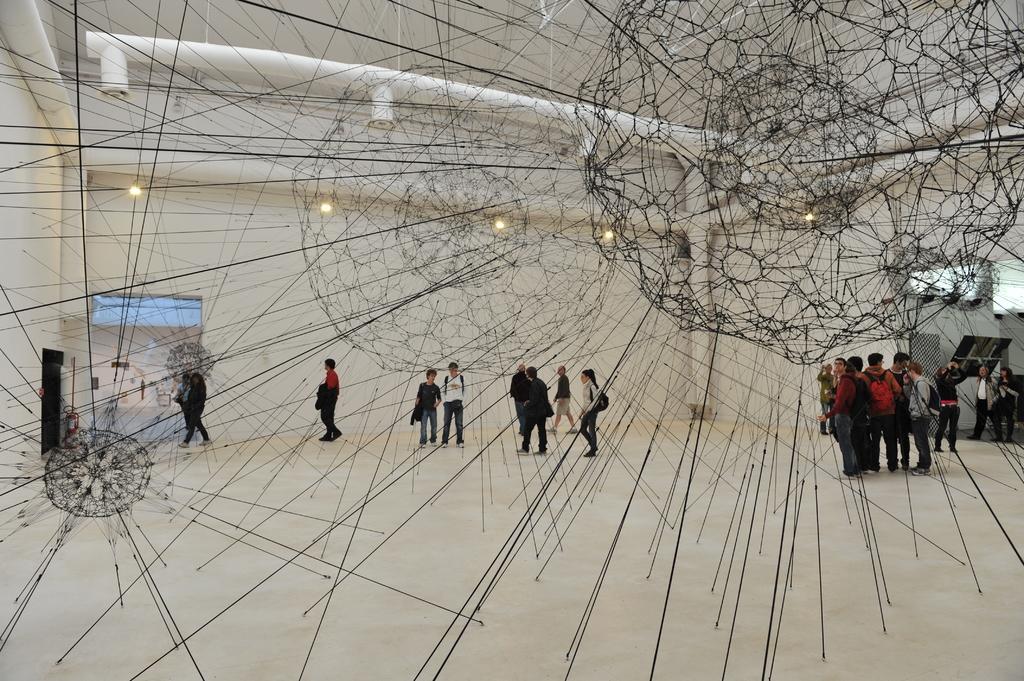Can you describe this image briefly? In the picture we can see a museum floor on it, we can see some iron sticks with some art and behind it, we can see some people are standing and some are walking through the entrance and to the ceiling we can see the lights. 